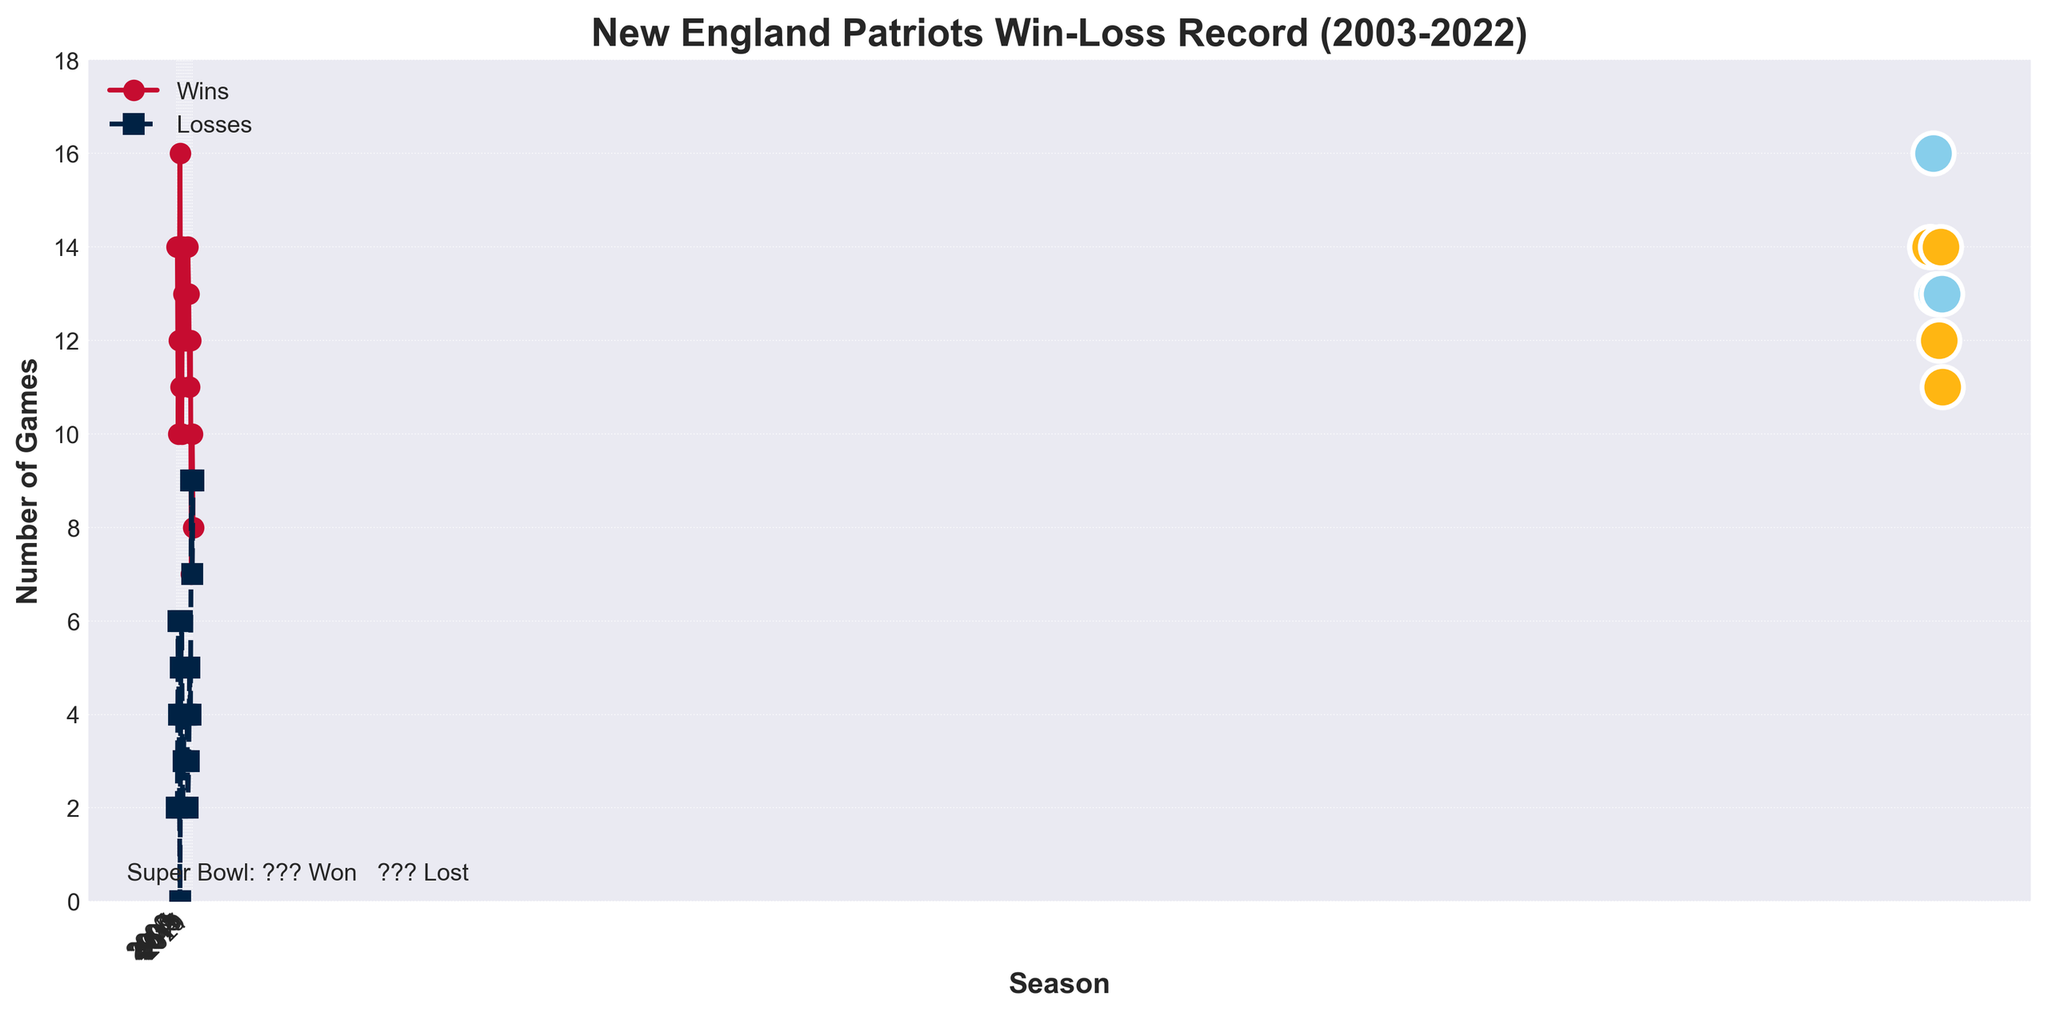Which season did the Patriots have the most wins? Look for the highest point on the red line representing wins. The highest point is at the 2007 season.
Answer: 2007 How many Super Bowl appearances did the Patriots make between 2003 and 2022? Count the number of instances with special markers indicating a Super Bowl appearance. There are 6 such markers in the plot.
Answer: 6 In which seasons did the Patriots win the Super Bowl? Identify the seasons with a yellow marker. The yellow markers appear in 2003, 2004, 2014, 2016, and 2018.
Answer: 2003, 2004, 2014, 2016, 2018 Which season had the highest number of losses, and what was that number? Look for the highest point on the blue dashed line representing losses. The highest point is at the 2020 season with 9 losses.
Answer: 2020, 9 What is the average number of wins over the 20 seasons? Sum all the wins and divide by the number of seasons: (14+14+10+12+16+11+10+14+13+12+12+12+12+14+13+11+12+7+10+8) / 20 = 220 / 20 = 11 wins on average.
Answer: 11 During which seasons did the Patriots lose the Super Bowl? Identify the seasons with a light blue marker. The light blue markers appear in 2007, 2011, and 2017.
Answer: 2007, 2011, 2017 Which season had an equal number of wins and losses? Look for the intersection point where both lines (wins and losses) touch or are close. The 2020 season shows a close intersection appearing almost at the same height.
Answer: 2020 How many more wins than losses did the Patriots have in 2010? Subtract the number of losses from the number of wins in 2010: 14 - 2 = 12 more wins.
Answer: 12 more wins In which seasons did the Patriots have exactly 12 wins? Identify points on the red line that match the '12' label on the y-axis. This occurs in 2006, 2012, 2013, 2014, and 2019.
Answer: 2006, 2012, 2013, 2014, 2019 Compare the wins in the 2003 and 2022 seasons. How many more wins were in 2003 compared to 2022? Subtract the 2022 wins from the 2003 wins: 14 - 8 = 6 more wins.
Answer: 6 more wins 